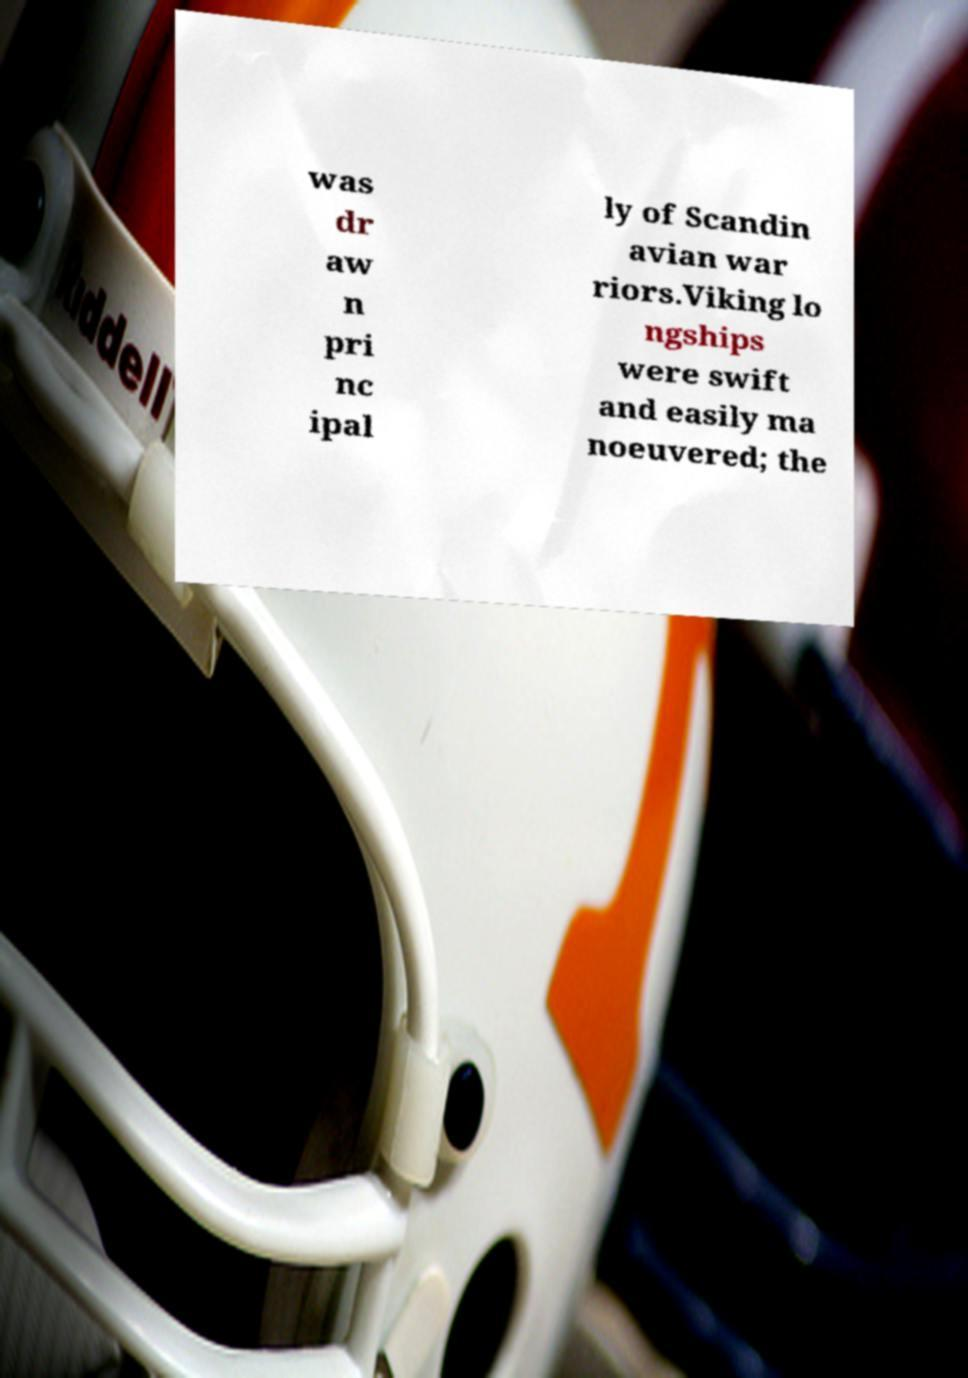There's text embedded in this image that I need extracted. Can you transcribe it verbatim? was dr aw n pri nc ipal ly of Scandin avian war riors.Viking lo ngships were swift and easily ma noeuvered; the 